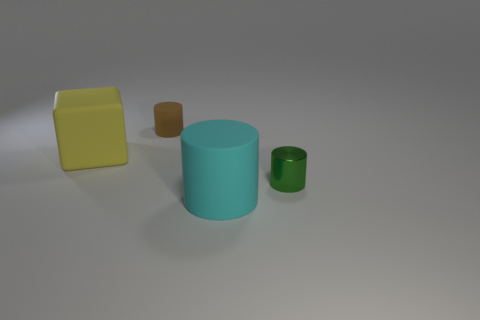Add 4 brown cylinders. How many objects exist? 8 Subtract all blocks. How many objects are left? 3 Add 2 big yellow blocks. How many big yellow blocks are left? 3 Add 1 cylinders. How many cylinders exist? 4 Subtract 1 brown cylinders. How many objects are left? 3 Subtract all tiny shiny cylinders. Subtract all tiny things. How many objects are left? 1 